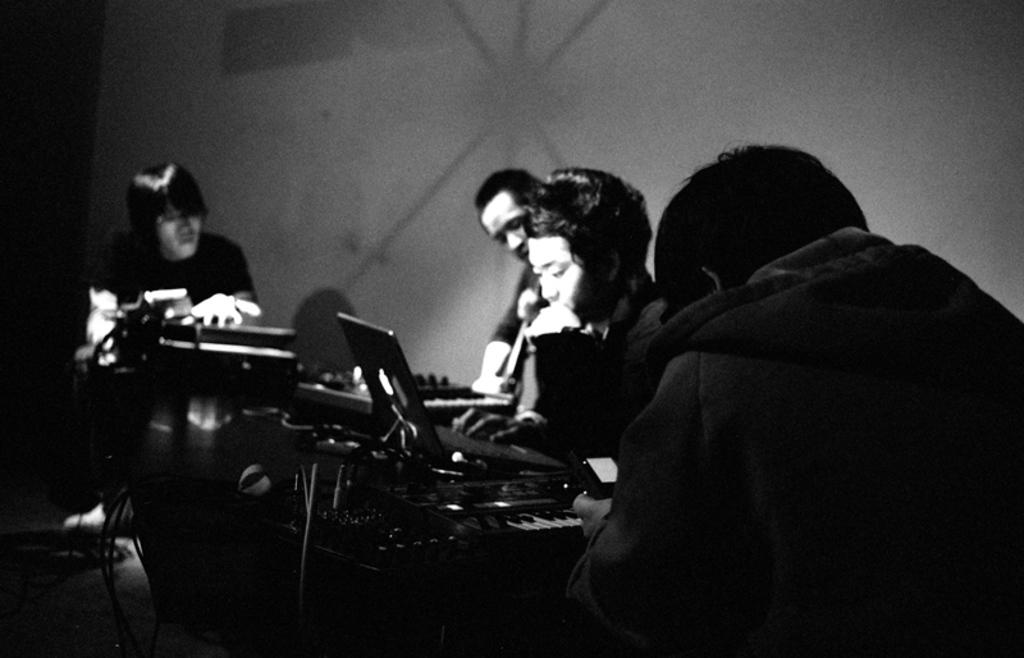What is the color scheme of the image? The image is black and white. What are the people in the image doing? A: There are persons sitting in the image. What else can be seen in the image besides the people? There are musical instruments in the image. What is the color of the background in the image? The background of the image is white in color. Can you hear the cough of the person sitting in the image? There is no sound in the image, so it is not possible to hear any coughing. What type of seed is being planted in the image? There is no seed or planting activity depicted in the image. 